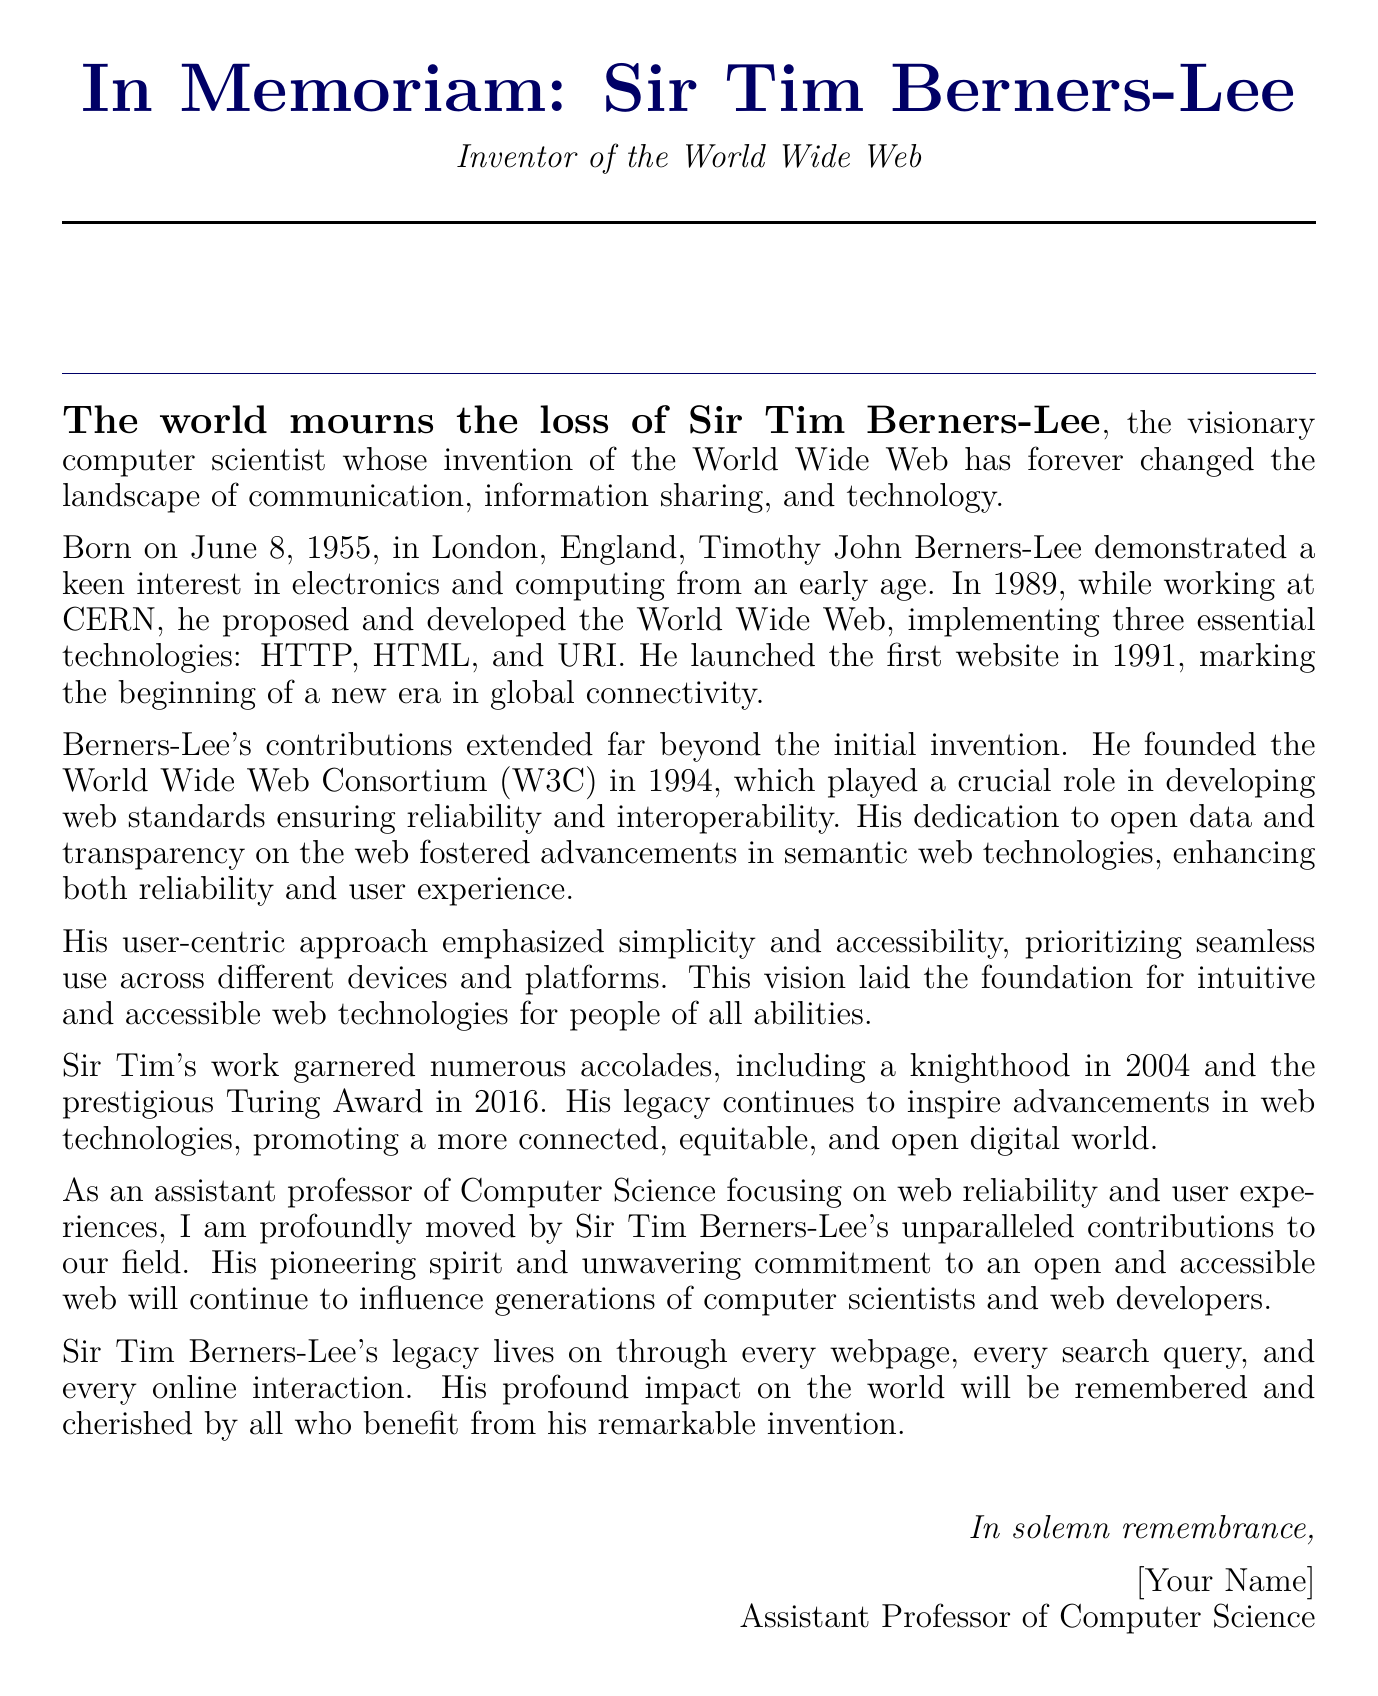What is the full name of the inventor of the World Wide Web? The document mentions "Timothy John Berners-Lee" as the full name of the inventor.
Answer: Timothy John Berners-Lee When was Sir Tim Berners-Lee born? The document states that he was born on June 8, 1955.
Answer: June 8, 1955 In which year did Berners-Lee launch the first website? The document indicates that the first website was launched in 1991.
Answer: 1991 What organization did Sir Tim Berners-Lee found in 1994? The document describes the founding of the "World Wide Web Consortium" in 1994.
Answer: World Wide Web Consortium What accolade did Sir Tim Berners-Lee receive in 2004? The document notes that he received a "knighthood" in 2004.
Answer: knighthood How did Berners-Lee prioritize user experience in web design? The document mentions that he emphasized "simplicity and accessibility."
Answer: simplicity and accessibility What vital web technologies did Tim Berners-Lee develop? The document states that he implemented "HTTP, HTML, and URI."
Answer: HTTP, HTML, and URI What is the significance of the World Wide Web Consortium (W3C)? The document explains that it played a crucial role in developing web "standards ensuring reliability and interoperability."
Answer: standards ensuring reliability and interoperability What is the legacy of Sir Tim Berners-Lee as stated in the document? The document highlights that his legacy promotes "a more connected, equitable, and open digital world."
Answer: a more connected, equitable, and open digital world 